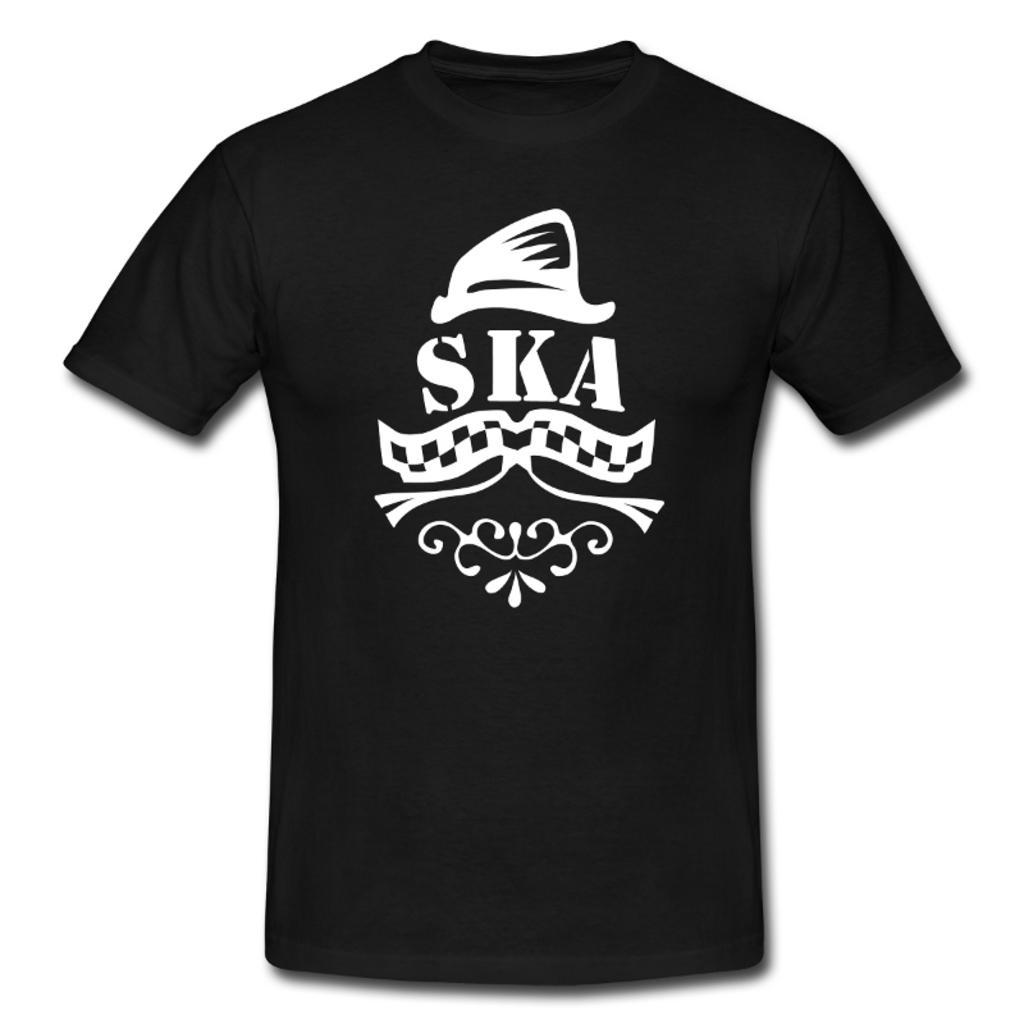How would you summarize this image in a sentence or two? In the middle I can see a black color t-shirt. The background is white in color. 